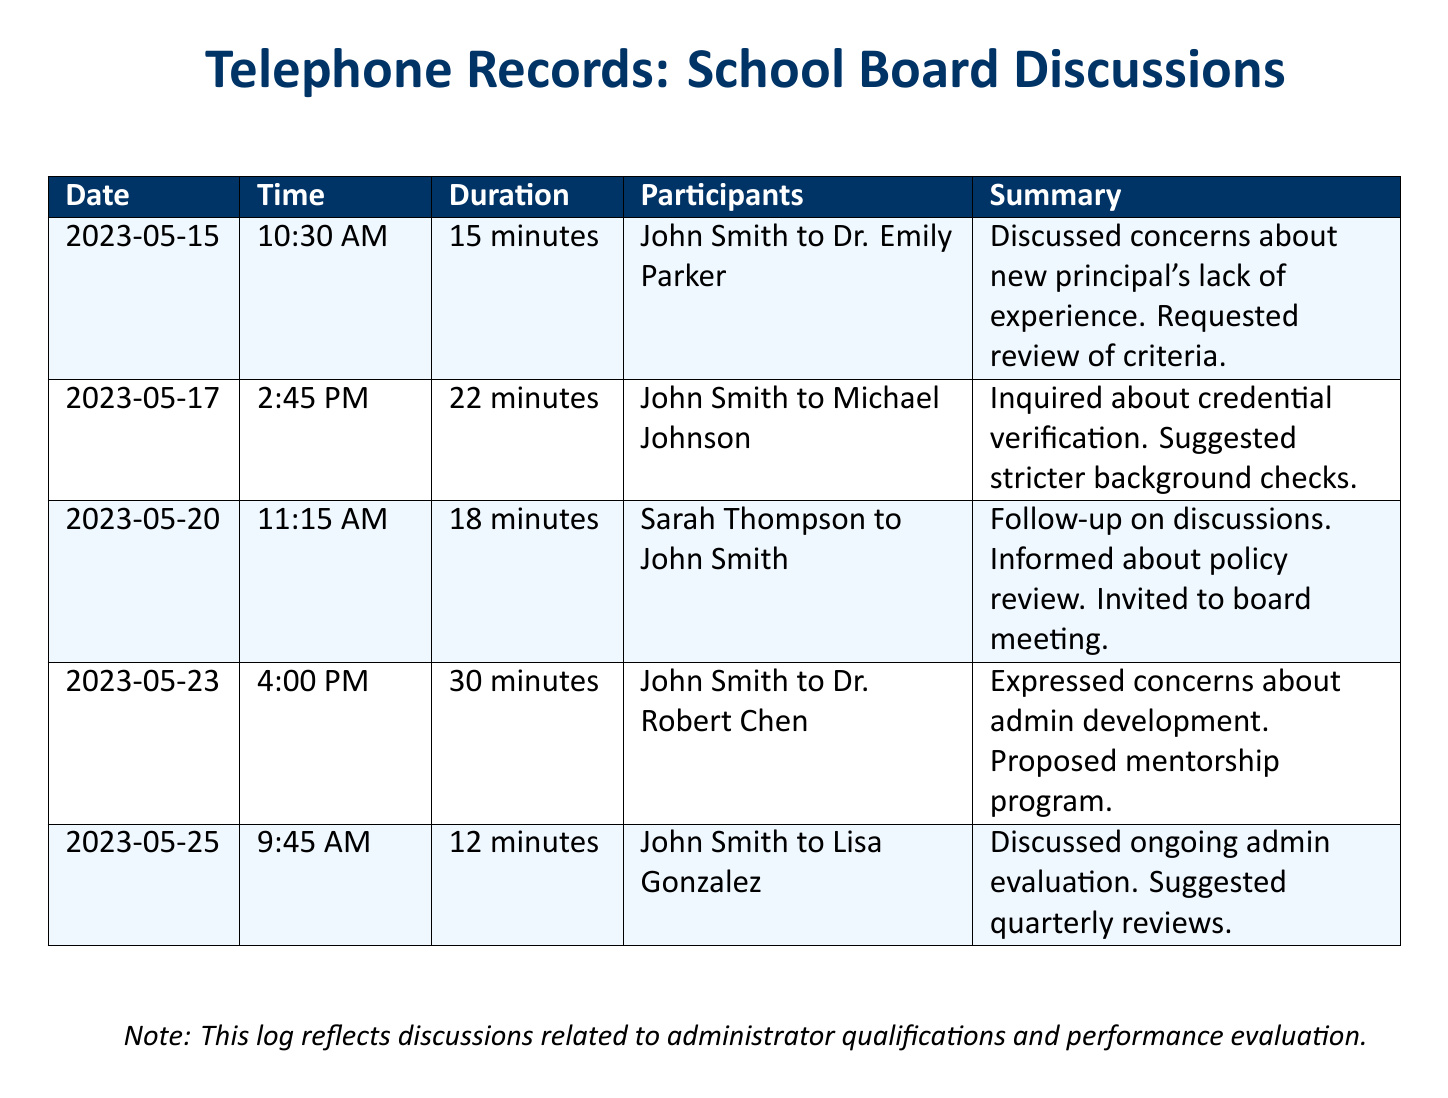What date did John Smith discuss the new principal's lack of experience? The date of the discussion regarding the new principal's lack of experience is found in the details of the first entry in the log.
Answer: 2023-05-15 Who participated in the conversation about credential verification? The conversation about credential verification involved John Smith and Michael Johnson, as listed in the second entry.
Answer: Michael Johnson How long did the discussion about admin development last? The duration of the discussion about admin development is indicated in the summary of the fourth entry.
Answer: 30 minutes What proposal did John Smith make during his call with Dr. Robert Chen? The proposal made during the call with Dr. Robert Chen involves a mentorship program, as stated in the summary.
Answer: Mentorship program How many participants were in the call regarding ongoing admin evaluation? The call regarding ongoing admin evaluation had two participants listed in the fifth entry of the log.
Answer: 2 What was suggested regarding administrator evaluations? The suggestion regarding administrator evaluations is found in the last call summary, which discusses frequency.
Answer: Quarterly reviews Who invited John Smith to the board meeting? The invitation to the board meeting was communicated by Sarah Thompson during their call, which is noted in the third entry.
Answer: Sarah Thompson On what date was the follow-up discussion about admin qualifications held? The follow-up discussion about admin qualifications took place on the date detailed in the third entry.
Answer: 2023-05-20 What key aspect was the focus of the discussions logged in this document? The focus of all discussions logged is about administrator qualifications and performance evaluation, as noted in the footer.
Answer: Administrator qualifications 